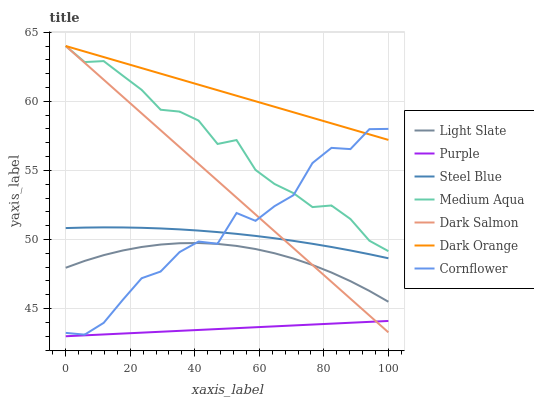Does Purple have the minimum area under the curve?
Answer yes or no. Yes. Does Dark Orange have the maximum area under the curve?
Answer yes or no. Yes. Does Cornflower have the minimum area under the curve?
Answer yes or no. No. Does Cornflower have the maximum area under the curve?
Answer yes or no. No. Is Dark Salmon the smoothest?
Answer yes or no. Yes. Is Cornflower the roughest?
Answer yes or no. Yes. Is Light Slate the smoothest?
Answer yes or no. No. Is Light Slate the roughest?
Answer yes or no. No. Does Purple have the lowest value?
Answer yes or no. Yes. Does Cornflower have the lowest value?
Answer yes or no. No. Does Medium Aqua have the highest value?
Answer yes or no. Yes. Does Cornflower have the highest value?
Answer yes or no. No. Is Purple less than Cornflower?
Answer yes or no. Yes. Is Dark Orange greater than Purple?
Answer yes or no. Yes. Does Medium Aqua intersect Dark Orange?
Answer yes or no. Yes. Is Medium Aqua less than Dark Orange?
Answer yes or no. No. Is Medium Aqua greater than Dark Orange?
Answer yes or no. No. Does Purple intersect Cornflower?
Answer yes or no. No. 